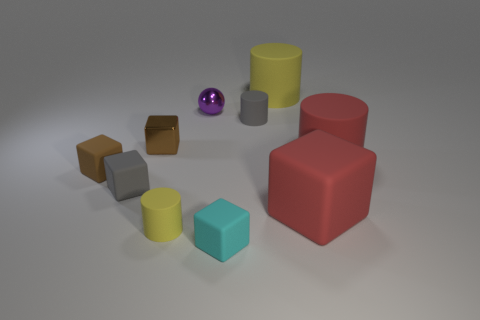Subtract 1 cubes. How many cubes are left? 4 Subtract all gray blocks. How many blocks are left? 4 Subtract all yellow cylinders. Subtract all yellow spheres. How many cylinders are left? 2 Subtract all balls. How many objects are left? 9 Add 1 big red cylinders. How many big red cylinders are left? 2 Add 4 yellow rubber cylinders. How many yellow rubber cylinders exist? 6 Subtract 2 yellow cylinders. How many objects are left? 8 Subtract all large cyan things. Subtract all small spheres. How many objects are left? 9 